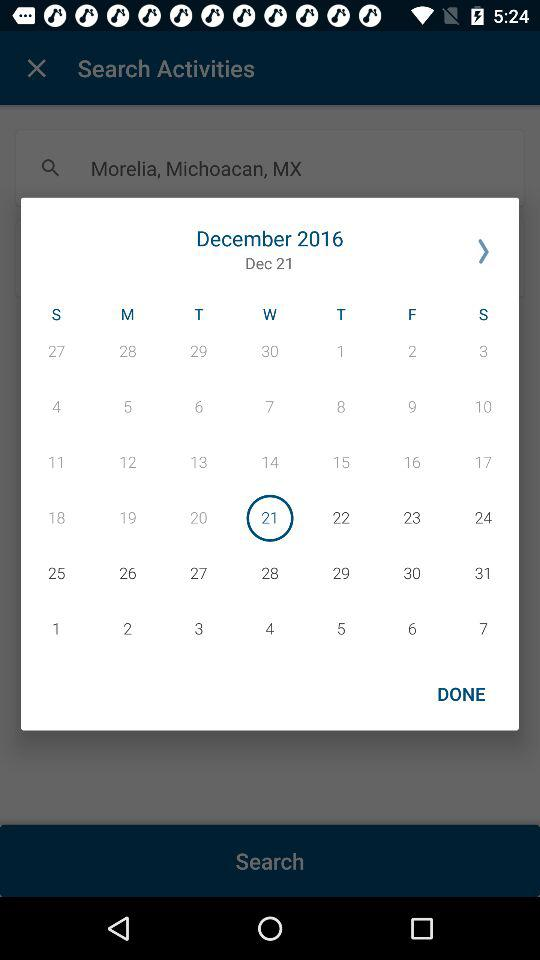What date is selected? The selected date is Wednesday, December 21, 2016. 